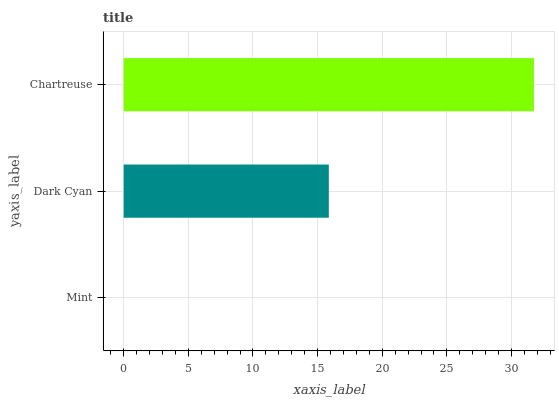Is Mint the minimum?
Answer yes or no. Yes. Is Chartreuse the maximum?
Answer yes or no. Yes. Is Dark Cyan the minimum?
Answer yes or no. No. Is Dark Cyan the maximum?
Answer yes or no. No. Is Dark Cyan greater than Mint?
Answer yes or no. Yes. Is Mint less than Dark Cyan?
Answer yes or no. Yes. Is Mint greater than Dark Cyan?
Answer yes or no. No. Is Dark Cyan less than Mint?
Answer yes or no. No. Is Dark Cyan the high median?
Answer yes or no. Yes. Is Dark Cyan the low median?
Answer yes or no. Yes. Is Mint the high median?
Answer yes or no. No. Is Mint the low median?
Answer yes or no. No. 